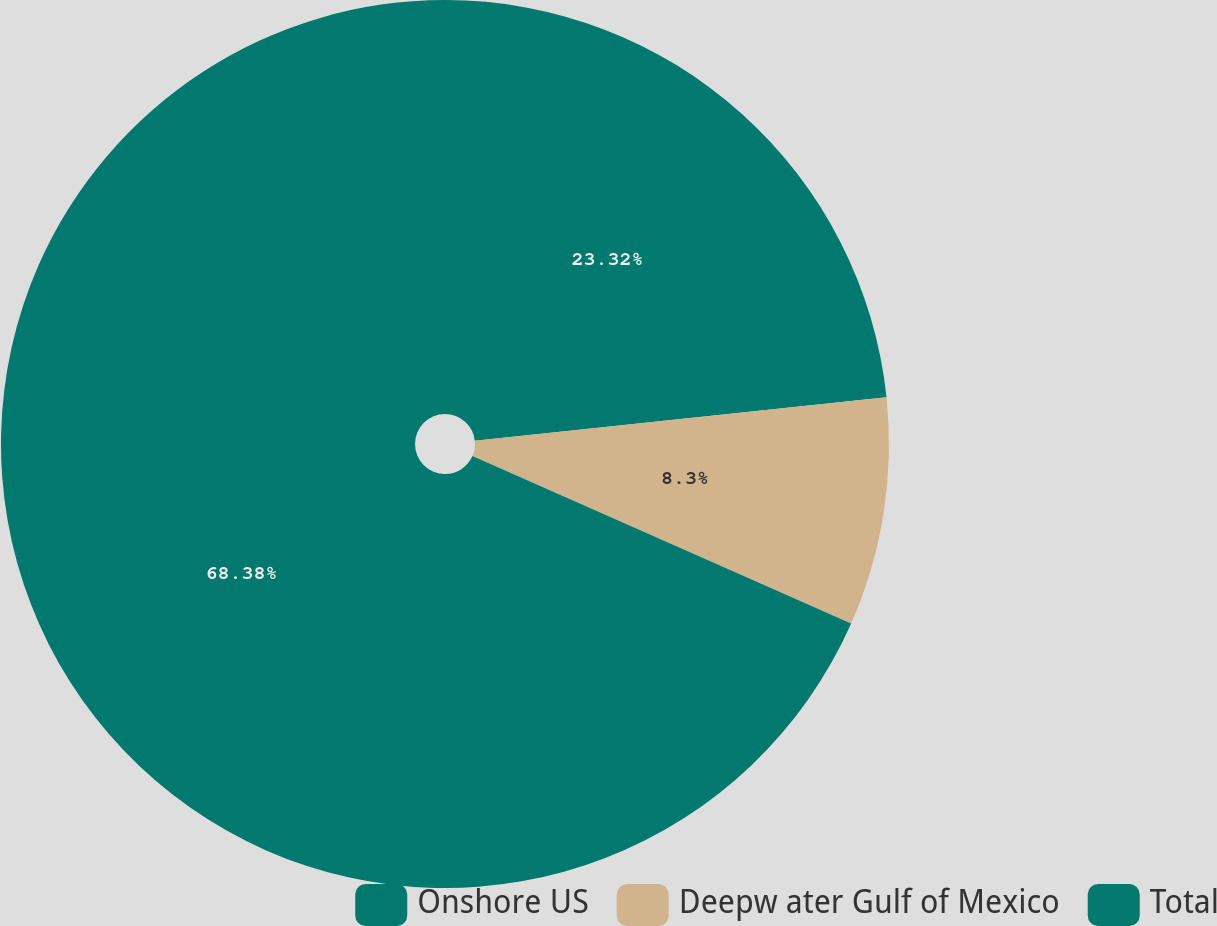Convert chart. <chart><loc_0><loc_0><loc_500><loc_500><pie_chart><fcel>Onshore US<fcel>Deepw ater Gulf of Mexico<fcel>Total<nl><fcel>23.32%<fcel>8.3%<fcel>68.38%<nl></chart> 